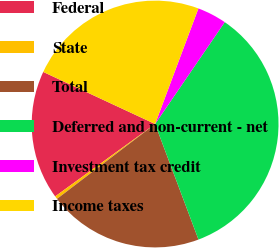Convert chart to OTSL. <chart><loc_0><loc_0><loc_500><loc_500><pie_chart><fcel>Federal<fcel>State<fcel>Total<fcel>Deferred and non-current - net<fcel>Investment tax credit<fcel>Income taxes<nl><fcel>16.91%<fcel>0.4%<fcel>20.34%<fcel>34.74%<fcel>3.84%<fcel>23.77%<nl></chart> 